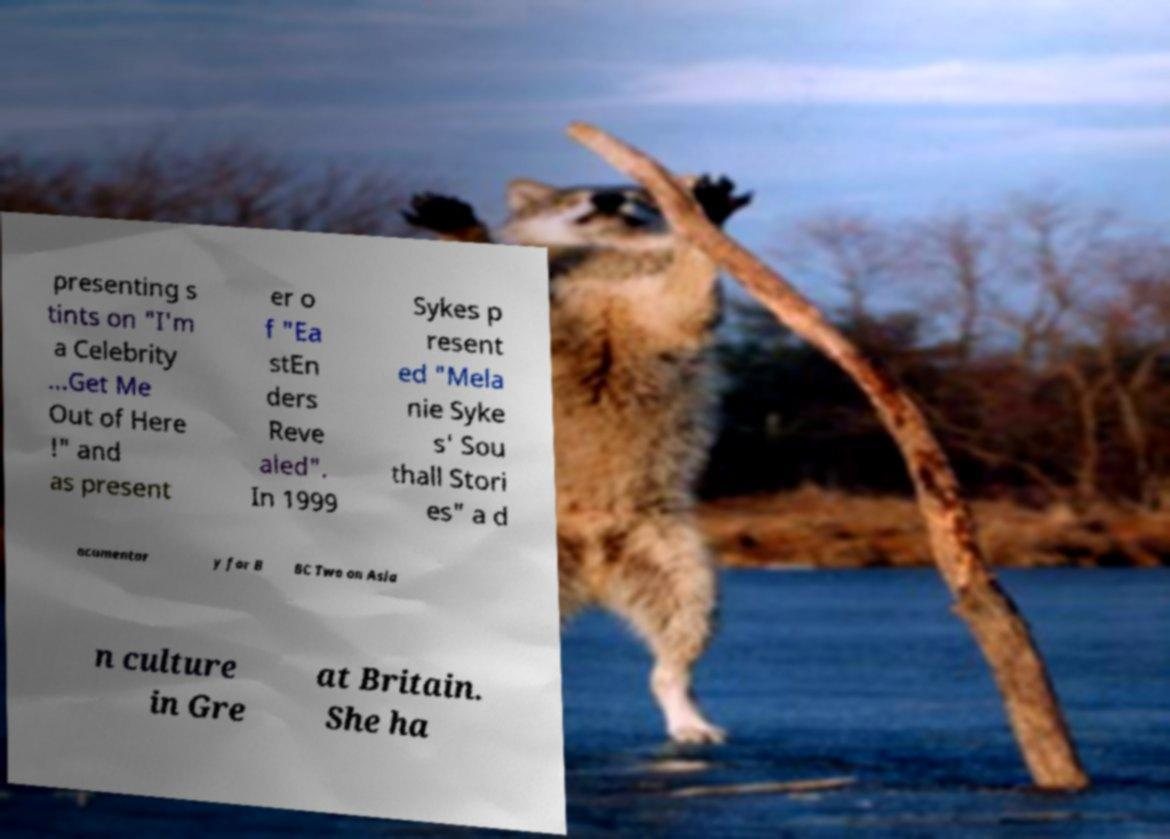Could you assist in decoding the text presented in this image and type it out clearly? presenting s tints on "I'm a Celebrity ...Get Me Out of Here !" and as present er o f "Ea stEn ders Reve aled". In 1999 Sykes p resent ed "Mela nie Syke s' Sou thall Stori es" a d ocumentar y for B BC Two on Asia n culture in Gre at Britain. She ha 